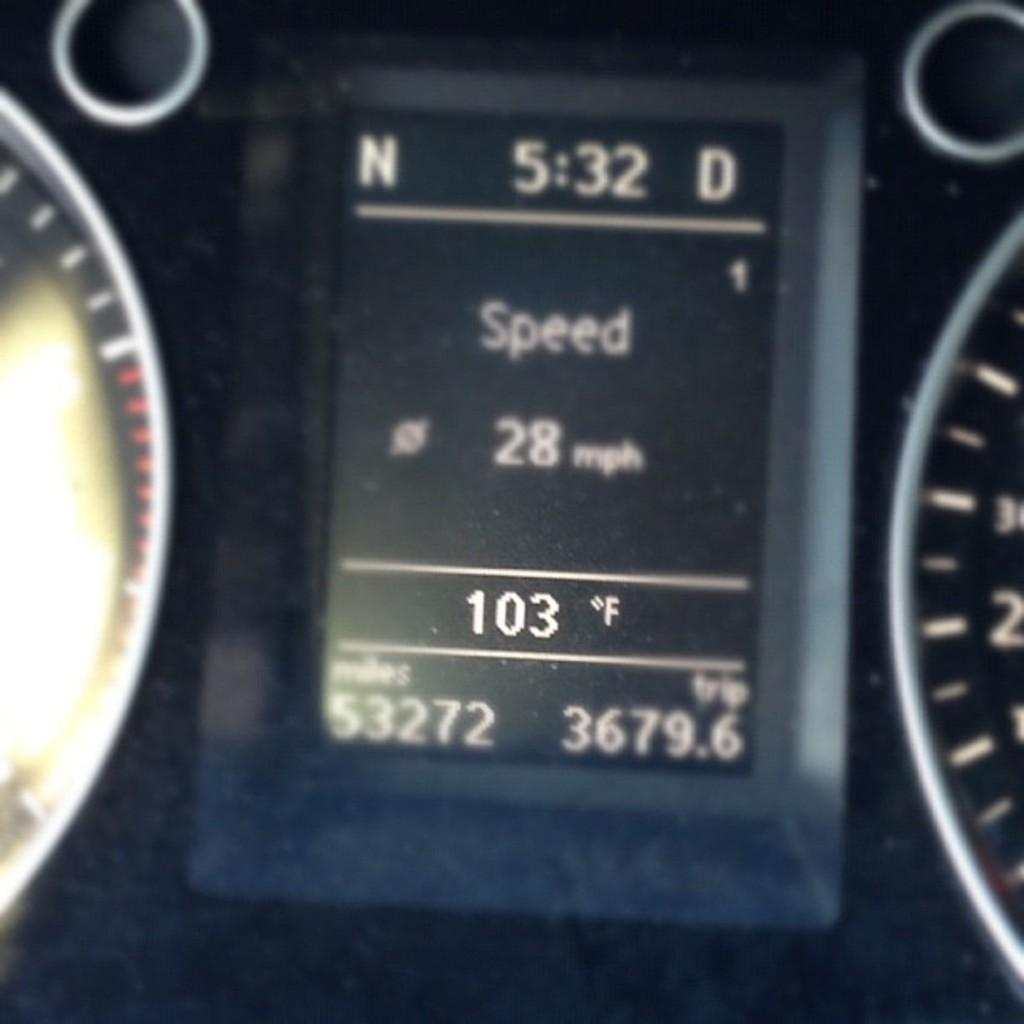What is the main object in the middle of the image? There is a digital display in the middle of the image. What else can be seen on either side of the digital display? There are meters on the right side and left side of the digital display. What information is visible on the digital display? There is text and numbers visible on the digital display. How many ants are crawling on the digital display in the image? There are no ants present in the image; the focus is on the digital display and its surrounding meters. 